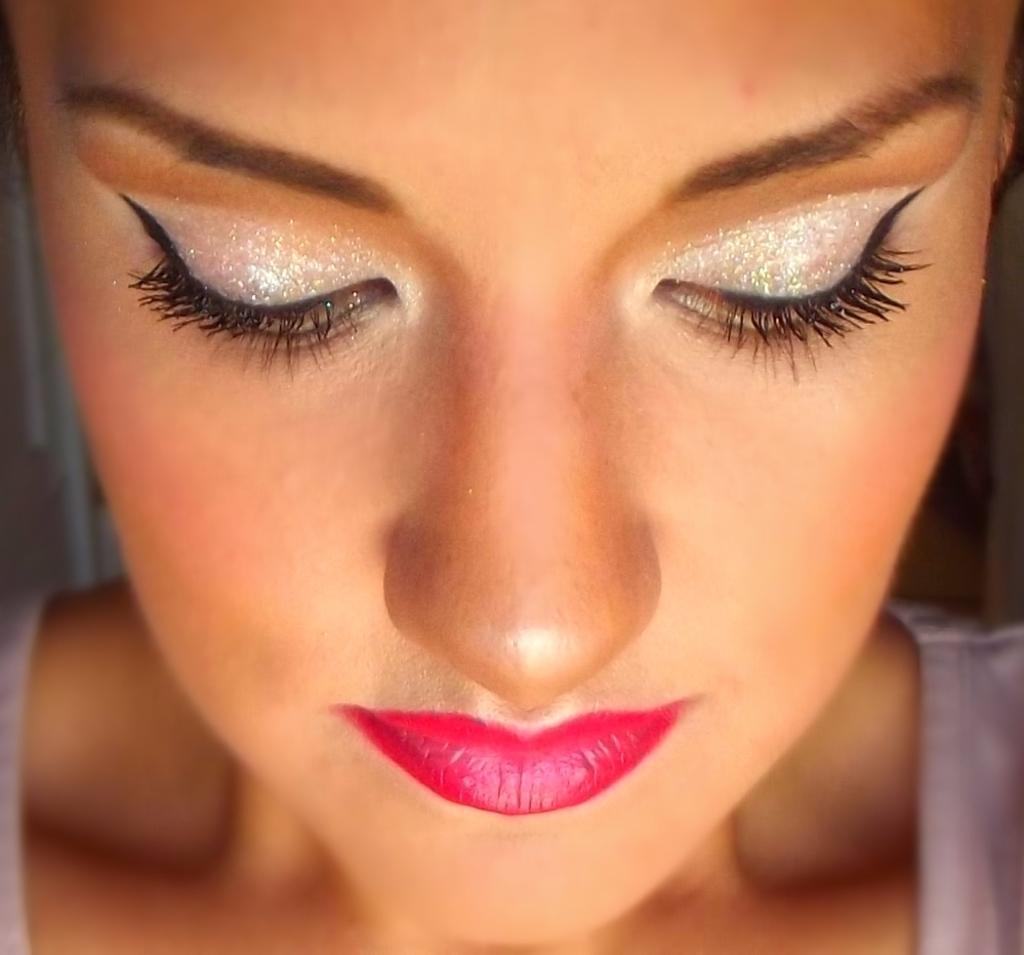Can you describe this image briefly? In this picture I can see the face of a person in which I can see red lips and eyeliner. 